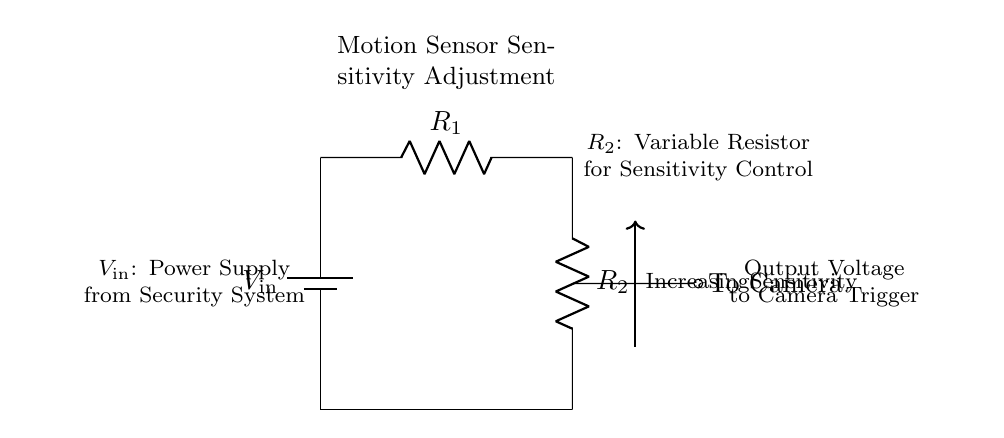What is the input voltage in the circuit? The input voltage is labeled as \( V_{\text{in}} \), which indicates the power supply voltage that powers the circuit.
Answer: V in What does the variable resistor \( R_2 \) control? \( R_2 \) is a variable resistor that adjusts the sensitivity of the motion sensor by changing the voltage output to the camera trigger based on its resistance value.
Answer: Sensitivity What is the total resistance in the series circuit? The total resistance in a series circuit with resistors \( R_1 \) and \( R_2 \) can be calculated by adding their resistances together. As the values are not specified, we cannot provide a numeric answer but indicate it as \( R_1 + R_2 \).
Answer: R 1 + R 2 What happens to the output voltage as \( R_2 \) is increased? As \( R_2 \) is increased, the output voltage to the camera increases due to the voltage divider principle, where a larger resistance reduces the proportion of voltage drop across \( R_1 \).
Answer: Increases What component connects to the motion sensor? The output from the voltage divider directly goes to the camera, which activates based on the sensitivity set by the variable resistor \( R_2 \). Therefore, this component is the camera.
Answer: Camera What is the purpose of the battery in the circuit? The battery provides the input power \( V_{\text{in}} \) necessary for the operation of the motion sensor and camera within the circuit.
Answer: Power supply 